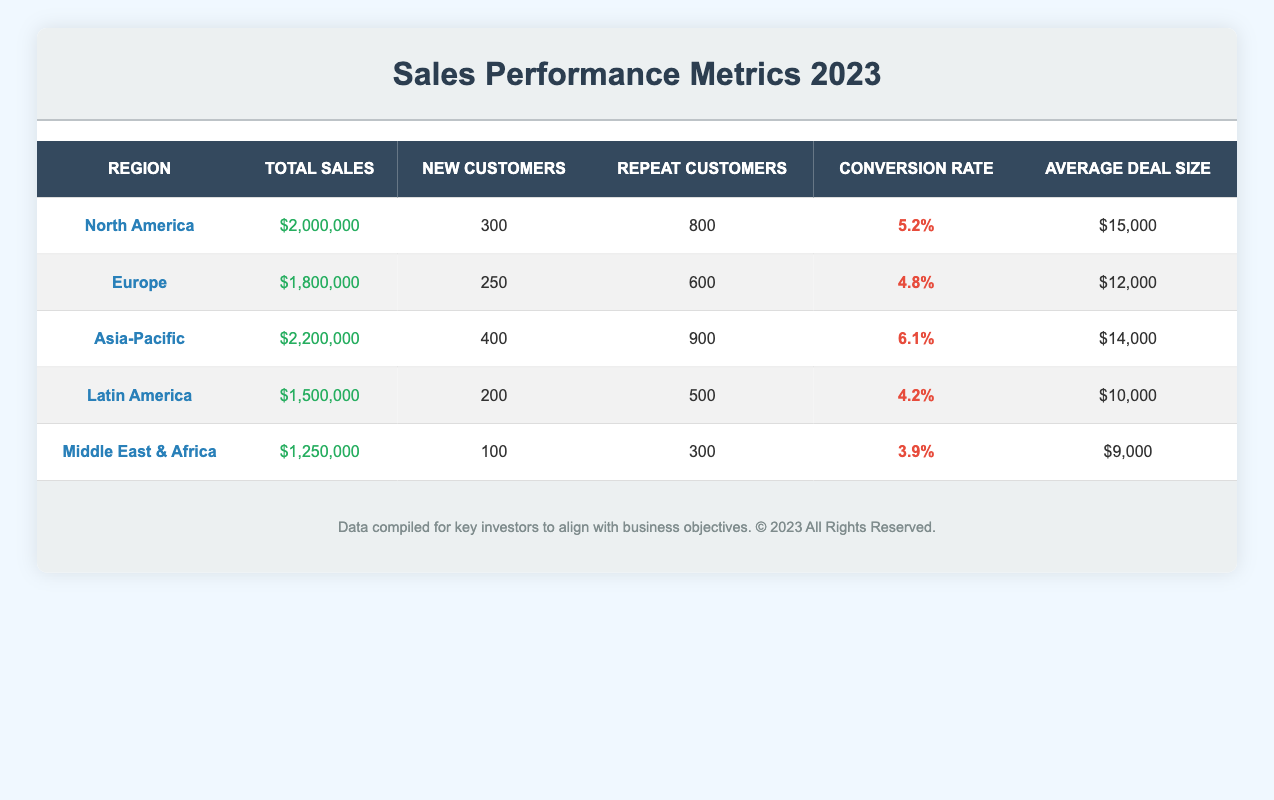What is the total sales for North America? The table shows North America has total sales listed as $2,000,000.
Answer: $2,000,000 Which region has the highest conversion rate? The conversion rates for all regions are: North America (5.2%), Europe (4.8%), Asia-Pacific (6.1%), Latin America (4.2%), and Middle East & Africa (3.9%). Among these, Asia-Pacific has the highest conversion rate at 6.1%.
Answer: Asia-Pacific How many new customers did Latin America acquire? The table lists Latin America as having 200 new customers.
Answer: 200 Calculate the average deal size across all regions. The average deal size can be calculated by summing the deal sizes: (15,000 + 12,000 + 14,000 + 10,000 + 9,000) = 60,000. There are 5 regions, so the average deal size is 60,000 divided by 5, which equals 12,000.
Answer: $12,000 Is the total sales for the Middle East & Africa more than $1,500,000? The table shows that the total sales for the Middle East & Africa is $1,250,000, which is less than $1,500,000.
Answer: No What is the total number of repeat customers in Asia-Pacific and North America combined? The table states that Asia-Pacific has 900 repeat customers and North America has 800. Adding these gives: 900 + 800 = 1,700.
Answer: 1,700 What percentage of new customers did the Middle East & Africa have compared to North America? The new customers for Middle East & Africa are 100, and for North America, they are 300. To find the percentage: (100/300) * 100 = 33.33%.
Answer: 33.33% Which region has both the highest total sales and the highest average deal size? The total sales for Asia-Pacific ($2,200,000) are the highest, and its average deal size is $14,000, while North America has a slightly lower total sales of $2,000,000 but a higher average deal size of $15,000. Therefore, these two metrics do not align in one region.
Answer: None 